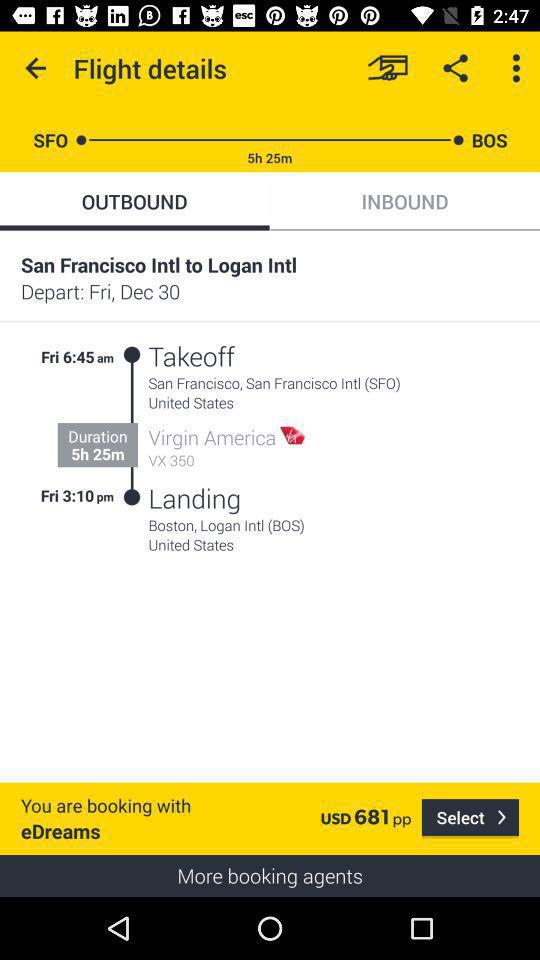What is the flight takeoff time? The flight takeoff time is 6:45 a.m. 